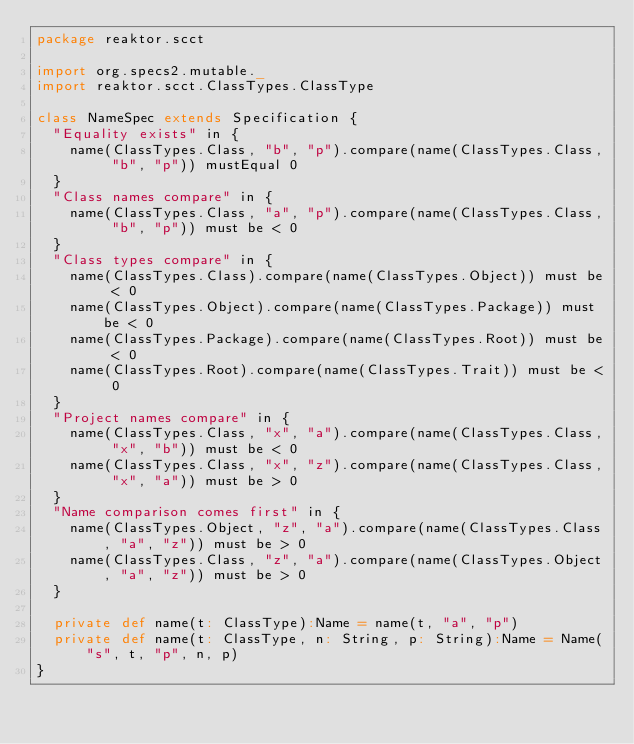<code> <loc_0><loc_0><loc_500><loc_500><_Scala_>package reaktor.scct

import org.specs2.mutable._
import reaktor.scct.ClassTypes.ClassType

class NameSpec extends Specification {
  "Equality exists" in {
    name(ClassTypes.Class, "b", "p").compare(name(ClassTypes.Class, "b", "p")) mustEqual 0
  }
  "Class names compare" in {
    name(ClassTypes.Class, "a", "p").compare(name(ClassTypes.Class, "b", "p")) must be < 0
  }
  "Class types compare" in {
    name(ClassTypes.Class).compare(name(ClassTypes.Object)) must be < 0
    name(ClassTypes.Object).compare(name(ClassTypes.Package)) must be < 0
    name(ClassTypes.Package).compare(name(ClassTypes.Root)) must be < 0
    name(ClassTypes.Root).compare(name(ClassTypes.Trait)) must be < 0
  }
  "Project names compare" in {
    name(ClassTypes.Class, "x", "a").compare(name(ClassTypes.Class, "x", "b")) must be < 0
    name(ClassTypes.Class, "x", "z").compare(name(ClassTypes.Class, "x", "a")) must be > 0
  }
  "Name comparison comes first" in {
    name(ClassTypes.Object, "z", "a").compare(name(ClassTypes.Class, "a", "z")) must be > 0
    name(ClassTypes.Class, "z", "a").compare(name(ClassTypes.Object, "a", "z")) must be > 0
  }

  private def name(t: ClassType):Name = name(t, "a", "p")
  private def name(t: ClassType, n: String, p: String):Name = Name("s", t, "p", n, p)
}</code> 